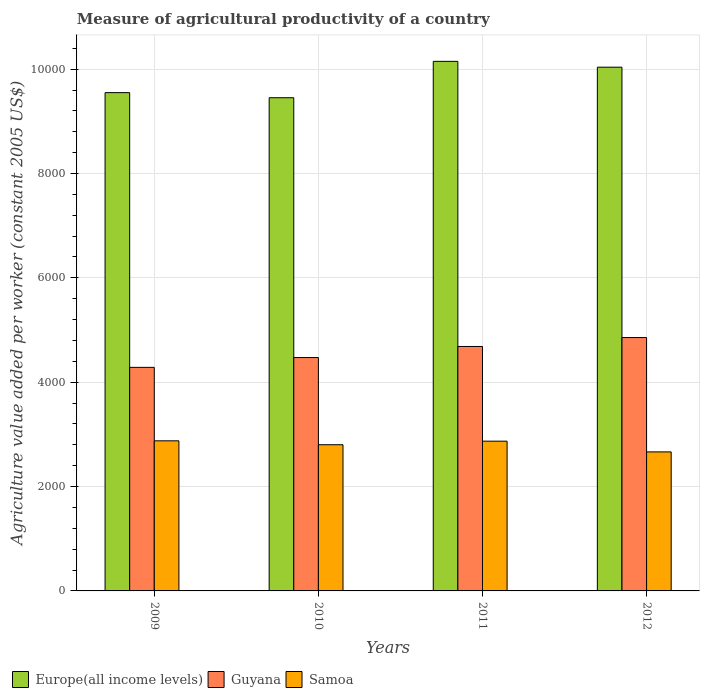How many groups of bars are there?
Offer a very short reply. 4. How many bars are there on the 4th tick from the left?
Ensure brevity in your answer.  3. How many bars are there on the 4th tick from the right?
Keep it short and to the point. 3. In how many cases, is the number of bars for a given year not equal to the number of legend labels?
Provide a short and direct response. 0. What is the measure of agricultural productivity in Samoa in 2010?
Provide a short and direct response. 2801.82. Across all years, what is the maximum measure of agricultural productivity in Guyana?
Offer a terse response. 4855.68. Across all years, what is the minimum measure of agricultural productivity in Samoa?
Keep it short and to the point. 2664.4. In which year was the measure of agricultural productivity in Europe(all income levels) maximum?
Offer a terse response. 2011. In which year was the measure of agricultural productivity in Europe(all income levels) minimum?
Your answer should be compact. 2010. What is the total measure of agricultural productivity in Samoa in the graph?
Offer a terse response. 1.12e+04. What is the difference between the measure of agricultural productivity in Samoa in 2009 and that in 2010?
Ensure brevity in your answer.  74.95. What is the difference between the measure of agricultural productivity in Guyana in 2010 and the measure of agricultural productivity in Europe(all income levels) in 2012?
Your answer should be compact. -5565.09. What is the average measure of agricultural productivity in Guyana per year?
Ensure brevity in your answer.  4574.24. In the year 2010, what is the difference between the measure of agricultural productivity in Guyana and measure of agricultural productivity in Europe(all income levels)?
Your answer should be very brief. -4979.58. What is the ratio of the measure of agricultural productivity in Guyana in 2009 to that in 2012?
Provide a short and direct response. 0.88. What is the difference between the highest and the second highest measure of agricultural productivity in Samoa?
Your response must be concise. 6.65. What is the difference between the highest and the lowest measure of agricultural productivity in Europe(all income levels)?
Offer a very short reply. 697.13. Is the sum of the measure of agricultural productivity in Samoa in 2009 and 2012 greater than the maximum measure of agricultural productivity in Europe(all income levels) across all years?
Your answer should be compact. No. What does the 3rd bar from the left in 2011 represents?
Offer a very short reply. Samoa. What does the 2nd bar from the right in 2011 represents?
Your answer should be very brief. Guyana. How many years are there in the graph?
Keep it short and to the point. 4. What is the title of the graph?
Your answer should be compact. Measure of agricultural productivity of a country. What is the label or title of the X-axis?
Your answer should be very brief. Years. What is the label or title of the Y-axis?
Keep it short and to the point. Agriculture value added per worker (constant 2005 US$). What is the Agriculture value added per worker (constant 2005 US$) of Europe(all income levels) in 2009?
Your answer should be very brief. 9549.65. What is the Agriculture value added per worker (constant 2005 US$) of Guyana in 2009?
Offer a terse response. 4284.26. What is the Agriculture value added per worker (constant 2005 US$) of Samoa in 2009?
Ensure brevity in your answer.  2876.76. What is the Agriculture value added per worker (constant 2005 US$) in Europe(all income levels) in 2010?
Make the answer very short. 9451.91. What is the Agriculture value added per worker (constant 2005 US$) in Guyana in 2010?
Your answer should be very brief. 4472.33. What is the Agriculture value added per worker (constant 2005 US$) in Samoa in 2010?
Ensure brevity in your answer.  2801.82. What is the Agriculture value added per worker (constant 2005 US$) of Europe(all income levels) in 2011?
Offer a very short reply. 1.01e+04. What is the Agriculture value added per worker (constant 2005 US$) in Guyana in 2011?
Your answer should be very brief. 4684.67. What is the Agriculture value added per worker (constant 2005 US$) in Samoa in 2011?
Provide a succinct answer. 2870.11. What is the Agriculture value added per worker (constant 2005 US$) of Europe(all income levels) in 2012?
Offer a very short reply. 1.00e+04. What is the Agriculture value added per worker (constant 2005 US$) of Guyana in 2012?
Give a very brief answer. 4855.68. What is the Agriculture value added per worker (constant 2005 US$) in Samoa in 2012?
Make the answer very short. 2664.4. Across all years, what is the maximum Agriculture value added per worker (constant 2005 US$) of Europe(all income levels)?
Provide a succinct answer. 1.01e+04. Across all years, what is the maximum Agriculture value added per worker (constant 2005 US$) of Guyana?
Keep it short and to the point. 4855.68. Across all years, what is the maximum Agriculture value added per worker (constant 2005 US$) of Samoa?
Provide a succinct answer. 2876.76. Across all years, what is the minimum Agriculture value added per worker (constant 2005 US$) of Europe(all income levels)?
Provide a short and direct response. 9451.91. Across all years, what is the minimum Agriculture value added per worker (constant 2005 US$) of Guyana?
Offer a very short reply. 4284.26. Across all years, what is the minimum Agriculture value added per worker (constant 2005 US$) of Samoa?
Offer a terse response. 2664.4. What is the total Agriculture value added per worker (constant 2005 US$) in Europe(all income levels) in the graph?
Your answer should be very brief. 3.92e+04. What is the total Agriculture value added per worker (constant 2005 US$) in Guyana in the graph?
Offer a very short reply. 1.83e+04. What is the total Agriculture value added per worker (constant 2005 US$) of Samoa in the graph?
Keep it short and to the point. 1.12e+04. What is the difference between the Agriculture value added per worker (constant 2005 US$) of Europe(all income levels) in 2009 and that in 2010?
Provide a short and direct response. 97.74. What is the difference between the Agriculture value added per worker (constant 2005 US$) in Guyana in 2009 and that in 2010?
Make the answer very short. -188.07. What is the difference between the Agriculture value added per worker (constant 2005 US$) of Samoa in 2009 and that in 2010?
Offer a terse response. 74.95. What is the difference between the Agriculture value added per worker (constant 2005 US$) of Europe(all income levels) in 2009 and that in 2011?
Keep it short and to the point. -599.39. What is the difference between the Agriculture value added per worker (constant 2005 US$) of Guyana in 2009 and that in 2011?
Ensure brevity in your answer.  -400.41. What is the difference between the Agriculture value added per worker (constant 2005 US$) of Samoa in 2009 and that in 2011?
Keep it short and to the point. 6.65. What is the difference between the Agriculture value added per worker (constant 2005 US$) of Europe(all income levels) in 2009 and that in 2012?
Your response must be concise. -487.77. What is the difference between the Agriculture value added per worker (constant 2005 US$) in Guyana in 2009 and that in 2012?
Provide a short and direct response. -571.42. What is the difference between the Agriculture value added per worker (constant 2005 US$) of Samoa in 2009 and that in 2012?
Provide a short and direct response. 212.36. What is the difference between the Agriculture value added per worker (constant 2005 US$) in Europe(all income levels) in 2010 and that in 2011?
Provide a short and direct response. -697.13. What is the difference between the Agriculture value added per worker (constant 2005 US$) in Guyana in 2010 and that in 2011?
Make the answer very short. -212.34. What is the difference between the Agriculture value added per worker (constant 2005 US$) of Samoa in 2010 and that in 2011?
Keep it short and to the point. -68.29. What is the difference between the Agriculture value added per worker (constant 2005 US$) in Europe(all income levels) in 2010 and that in 2012?
Give a very brief answer. -585.51. What is the difference between the Agriculture value added per worker (constant 2005 US$) in Guyana in 2010 and that in 2012?
Your answer should be very brief. -383.35. What is the difference between the Agriculture value added per worker (constant 2005 US$) of Samoa in 2010 and that in 2012?
Your response must be concise. 137.41. What is the difference between the Agriculture value added per worker (constant 2005 US$) of Europe(all income levels) in 2011 and that in 2012?
Provide a succinct answer. 111.62. What is the difference between the Agriculture value added per worker (constant 2005 US$) in Guyana in 2011 and that in 2012?
Offer a terse response. -171.01. What is the difference between the Agriculture value added per worker (constant 2005 US$) in Samoa in 2011 and that in 2012?
Make the answer very short. 205.71. What is the difference between the Agriculture value added per worker (constant 2005 US$) in Europe(all income levels) in 2009 and the Agriculture value added per worker (constant 2005 US$) in Guyana in 2010?
Your response must be concise. 5077.32. What is the difference between the Agriculture value added per worker (constant 2005 US$) of Europe(all income levels) in 2009 and the Agriculture value added per worker (constant 2005 US$) of Samoa in 2010?
Your response must be concise. 6747.84. What is the difference between the Agriculture value added per worker (constant 2005 US$) of Guyana in 2009 and the Agriculture value added per worker (constant 2005 US$) of Samoa in 2010?
Offer a terse response. 1482.45. What is the difference between the Agriculture value added per worker (constant 2005 US$) of Europe(all income levels) in 2009 and the Agriculture value added per worker (constant 2005 US$) of Guyana in 2011?
Keep it short and to the point. 4864.98. What is the difference between the Agriculture value added per worker (constant 2005 US$) of Europe(all income levels) in 2009 and the Agriculture value added per worker (constant 2005 US$) of Samoa in 2011?
Offer a very short reply. 6679.54. What is the difference between the Agriculture value added per worker (constant 2005 US$) of Guyana in 2009 and the Agriculture value added per worker (constant 2005 US$) of Samoa in 2011?
Offer a very short reply. 1414.16. What is the difference between the Agriculture value added per worker (constant 2005 US$) in Europe(all income levels) in 2009 and the Agriculture value added per worker (constant 2005 US$) in Guyana in 2012?
Your answer should be very brief. 4693.97. What is the difference between the Agriculture value added per worker (constant 2005 US$) in Europe(all income levels) in 2009 and the Agriculture value added per worker (constant 2005 US$) in Samoa in 2012?
Provide a short and direct response. 6885.25. What is the difference between the Agriculture value added per worker (constant 2005 US$) of Guyana in 2009 and the Agriculture value added per worker (constant 2005 US$) of Samoa in 2012?
Give a very brief answer. 1619.86. What is the difference between the Agriculture value added per worker (constant 2005 US$) of Europe(all income levels) in 2010 and the Agriculture value added per worker (constant 2005 US$) of Guyana in 2011?
Give a very brief answer. 4767.23. What is the difference between the Agriculture value added per worker (constant 2005 US$) of Europe(all income levels) in 2010 and the Agriculture value added per worker (constant 2005 US$) of Samoa in 2011?
Your answer should be compact. 6581.8. What is the difference between the Agriculture value added per worker (constant 2005 US$) in Guyana in 2010 and the Agriculture value added per worker (constant 2005 US$) in Samoa in 2011?
Your answer should be compact. 1602.22. What is the difference between the Agriculture value added per worker (constant 2005 US$) of Europe(all income levels) in 2010 and the Agriculture value added per worker (constant 2005 US$) of Guyana in 2012?
Offer a very short reply. 4596.23. What is the difference between the Agriculture value added per worker (constant 2005 US$) of Europe(all income levels) in 2010 and the Agriculture value added per worker (constant 2005 US$) of Samoa in 2012?
Provide a short and direct response. 6787.51. What is the difference between the Agriculture value added per worker (constant 2005 US$) of Guyana in 2010 and the Agriculture value added per worker (constant 2005 US$) of Samoa in 2012?
Ensure brevity in your answer.  1807.93. What is the difference between the Agriculture value added per worker (constant 2005 US$) in Europe(all income levels) in 2011 and the Agriculture value added per worker (constant 2005 US$) in Guyana in 2012?
Provide a succinct answer. 5293.36. What is the difference between the Agriculture value added per worker (constant 2005 US$) of Europe(all income levels) in 2011 and the Agriculture value added per worker (constant 2005 US$) of Samoa in 2012?
Your answer should be very brief. 7484.64. What is the difference between the Agriculture value added per worker (constant 2005 US$) in Guyana in 2011 and the Agriculture value added per worker (constant 2005 US$) in Samoa in 2012?
Give a very brief answer. 2020.27. What is the average Agriculture value added per worker (constant 2005 US$) of Europe(all income levels) per year?
Give a very brief answer. 9797.01. What is the average Agriculture value added per worker (constant 2005 US$) of Guyana per year?
Provide a succinct answer. 4574.24. What is the average Agriculture value added per worker (constant 2005 US$) in Samoa per year?
Keep it short and to the point. 2803.27. In the year 2009, what is the difference between the Agriculture value added per worker (constant 2005 US$) in Europe(all income levels) and Agriculture value added per worker (constant 2005 US$) in Guyana?
Make the answer very short. 5265.39. In the year 2009, what is the difference between the Agriculture value added per worker (constant 2005 US$) in Europe(all income levels) and Agriculture value added per worker (constant 2005 US$) in Samoa?
Provide a succinct answer. 6672.89. In the year 2009, what is the difference between the Agriculture value added per worker (constant 2005 US$) of Guyana and Agriculture value added per worker (constant 2005 US$) of Samoa?
Your response must be concise. 1407.5. In the year 2010, what is the difference between the Agriculture value added per worker (constant 2005 US$) in Europe(all income levels) and Agriculture value added per worker (constant 2005 US$) in Guyana?
Ensure brevity in your answer.  4979.58. In the year 2010, what is the difference between the Agriculture value added per worker (constant 2005 US$) in Europe(all income levels) and Agriculture value added per worker (constant 2005 US$) in Samoa?
Your response must be concise. 6650.09. In the year 2010, what is the difference between the Agriculture value added per worker (constant 2005 US$) of Guyana and Agriculture value added per worker (constant 2005 US$) of Samoa?
Your answer should be very brief. 1670.52. In the year 2011, what is the difference between the Agriculture value added per worker (constant 2005 US$) in Europe(all income levels) and Agriculture value added per worker (constant 2005 US$) in Guyana?
Provide a short and direct response. 5464.37. In the year 2011, what is the difference between the Agriculture value added per worker (constant 2005 US$) in Europe(all income levels) and Agriculture value added per worker (constant 2005 US$) in Samoa?
Ensure brevity in your answer.  7278.93. In the year 2011, what is the difference between the Agriculture value added per worker (constant 2005 US$) in Guyana and Agriculture value added per worker (constant 2005 US$) in Samoa?
Make the answer very short. 1814.57. In the year 2012, what is the difference between the Agriculture value added per worker (constant 2005 US$) in Europe(all income levels) and Agriculture value added per worker (constant 2005 US$) in Guyana?
Your answer should be very brief. 5181.74. In the year 2012, what is the difference between the Agriculture value added per worker (constant 2005 US$) of Europe(all income levels) and Agriculture value added per worker (constant 2005 US$) of Samoa?
Provide a succinct answer. 7373.02. In the year 2012, what is the difference between the Agriculture value added per worker (constant 2005 US$) in Guyana and Agriculture value added per worker (constant 2005 US$) in Samoa?
Offer a terse response. 2191.28. What is the ratio of the Agriculture value added per worker (constant 2005 US$) in Europe(all income levels) in 2009 to that in 2010?
Make the answer very short. 1.01. What is the ratio of the Agriculture value added per worker (constant 2005 US$) of Guyana in 2009 to that in 2010?
Provide a succinct answer. 0.96. What is the ratio of the Agriculture value added per worker (constant 2005 US$) of Samoa in 2009 to that in 2010?
Your answer should be compact. 1.03. What is the ratio of the Agriculture value added per worker (constant 2005 US$) in Europe(all income levels) in 2009 to that in 2011?
Your answer should be compact. 0.94. What is the ratio of the Agriculture value added per worker (constant 2005 US$) of Guyana in 2009 to that in 2011?
Your answer should be compact. 0.91. What is the ratio of the Agriculture value added per worker (constant 2005 US$) in Samoa in 2009 to that in 2011?
Give a very brief answer. 1. What is the ratio of the Agriculture value added per worker (constant 2005 US$) in Europe(all income levels) in 2009 to that in 2012?
Your answer should be very brief. 0.95. What is the ratio of the Agriculture value added per worker (constant 2005 US$) of Guyana in 2009 to that in 2012?
Your answer should be very brief. 0.88. What is the ratio of the Agriculture value added per worker (constant 2005 US$) in Samoa in 2009 to that in 2012?
Offer a very short reply. 1.08. What is the ratio of the Agriculture value added per worker (constant 2005 US$) in Europe(all income levels) in 2010 to that in 2011?
Give a very brief answer. 0.93. What is the ratio of the Agriculture value added per worker (constant 2005 US$) in Guyana in 2010 to that in 2011?
Your response must be concise. 0.95. What is the ratio of the Agriculture value added per worker (constant 2005 US$) of Samoa in 2010 to that in 2011?
Keep it short and to the point. 0.98. What is the ratio of the Agriculture value added per worker (constant 2005 US$) of Europe(all income levels) in 2010 to that in 2012?
Offer a very short reply. 0.94. What is the ratio of the Agriculture value added per worker (constant 2005 US$) of Guyana in 2010 to that in 2012?
Provide a short and direct response. 0.92. What is the ratio of the Agriculture value added per worker (constant 2005 US$) in Samoa in 2010 to that in 2012?
Make the answer very short. 1.05. What is the ratio of the Agriculture value added per worker (constant 2005 US$) in Europe(all income levels) in 2011 to that in 2012?
Your response must be concise. 1.01. What is the ratio of the Agriculture value added per worker (constant 2005 US$) of Guyana in 2011 to that in 2012?
Provide a short and direct response. 0.96. What is the ratio of the Agriculture value added per worker (constant 2005 US$) of Samoa in 2011 to that in 2012?
Provide a short and direct response. 1.08. What is the difference between the highest and the second highest Agriculture value added per worker (constant 2005 US$) of Europe(all income levels)?
Your answer should be compact. 111.62. What is the difference between the highest and the second highest Agriculture value added per worker (constant 2005 US$) in Guyana?
Your response must be concise. 171.01. What is the difference between the highest and the second highest Agriculture value added per worker (constant 2005 US$) in Samoa?
Keep it short and to the point. 6.65. What is the difference between the highest and the lowest Agriculture value added per worker (constant 2005 US$) in Europe(all income levels)?
Your answer should be compact. 697.13. What is the difference between the highest and the lowest Agriculture value added per worker (constant 2005 US$) of Guyana?
Your answer should be very brief. 571.42. What is the difference between the highest and the lowest Agriculture value added per worker (constant 2005 US$) of Samoa?
Provide a short and direct response. 212.36. 